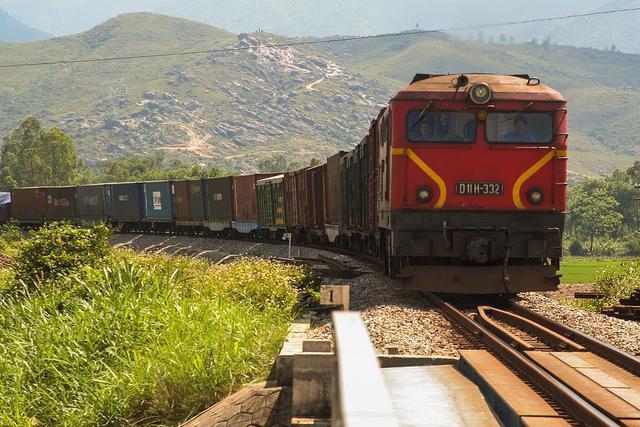How many sinks are there in this room?
Give a very brief answer. 0. 